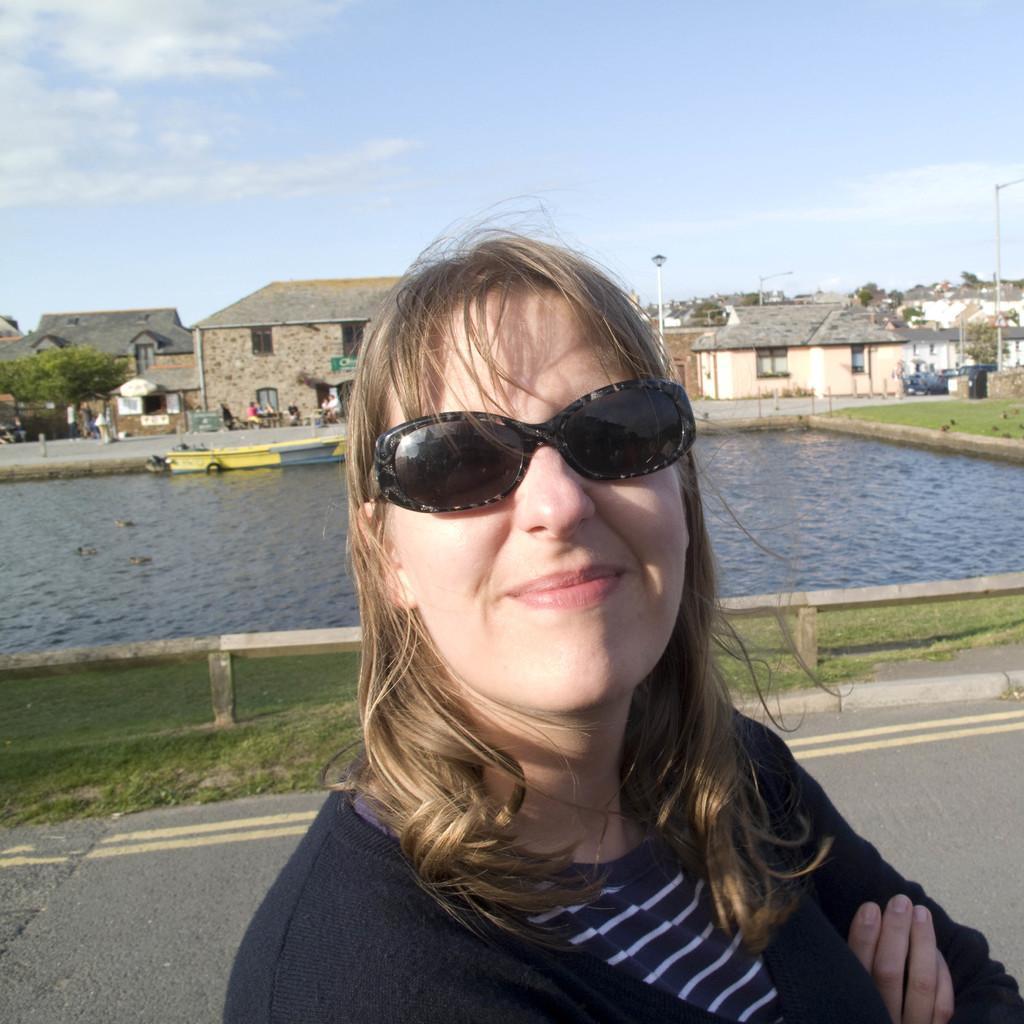Can you describe this image briefly? In this image I can see a woman and I can see she is wearing black dress. I can also see she is wearing black shades and I can see smile on her face. In the background I can see grass, water, buildings, trees, few poles, a light, clouds and sky. In water I can see a yellow colour boat and I can also see few people over there. 